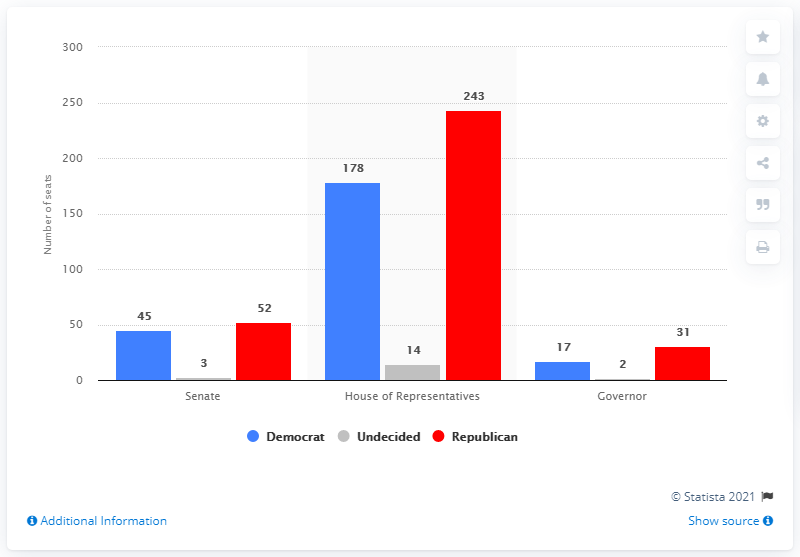Indicate a few pertinent items in this graphic. As of November 6, the Republican Party held 52 seats in the new Senate. 